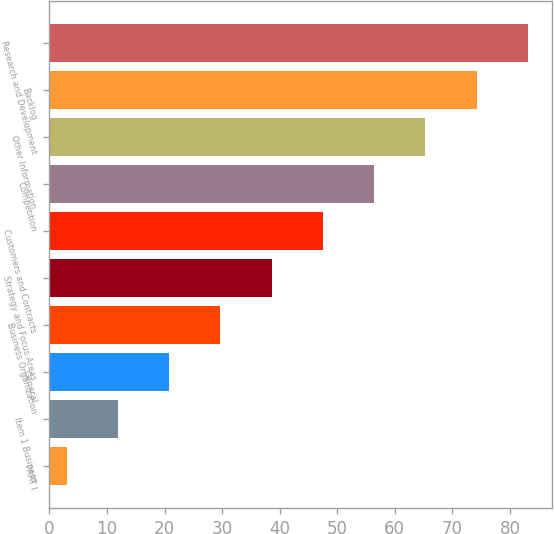<chart> <loc_0><loc_0><loc_500><loc_500><bar_chart><fcel>PART I<fcel>Item 1 Business<fcel>General<fcel>Business Organization<fcel>Strategy and Focus Areas<fcel>Customers and Contracts<fcel>Competition<fcel>Other Information<fcel>Backlog<fcel>Research and Development<nl><fcel>3<fcel>11.9<fcel>20.8<fcel>29.7<fcel>38.6<fcel>47.5<fcel>56.4<fcel>65.3<fcel>74.2<fcel>83.1<nl></chart> 